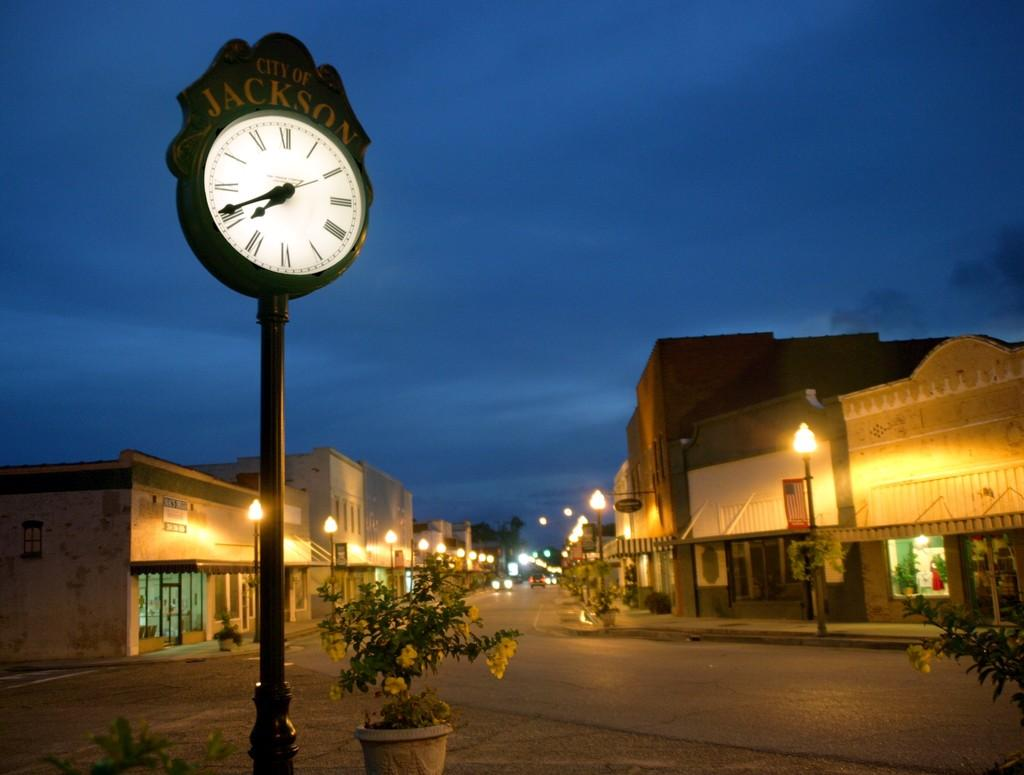<image>
Share a concise interpretation of the image provided. A City of Jackson clock stands against a night sky in an empty town 